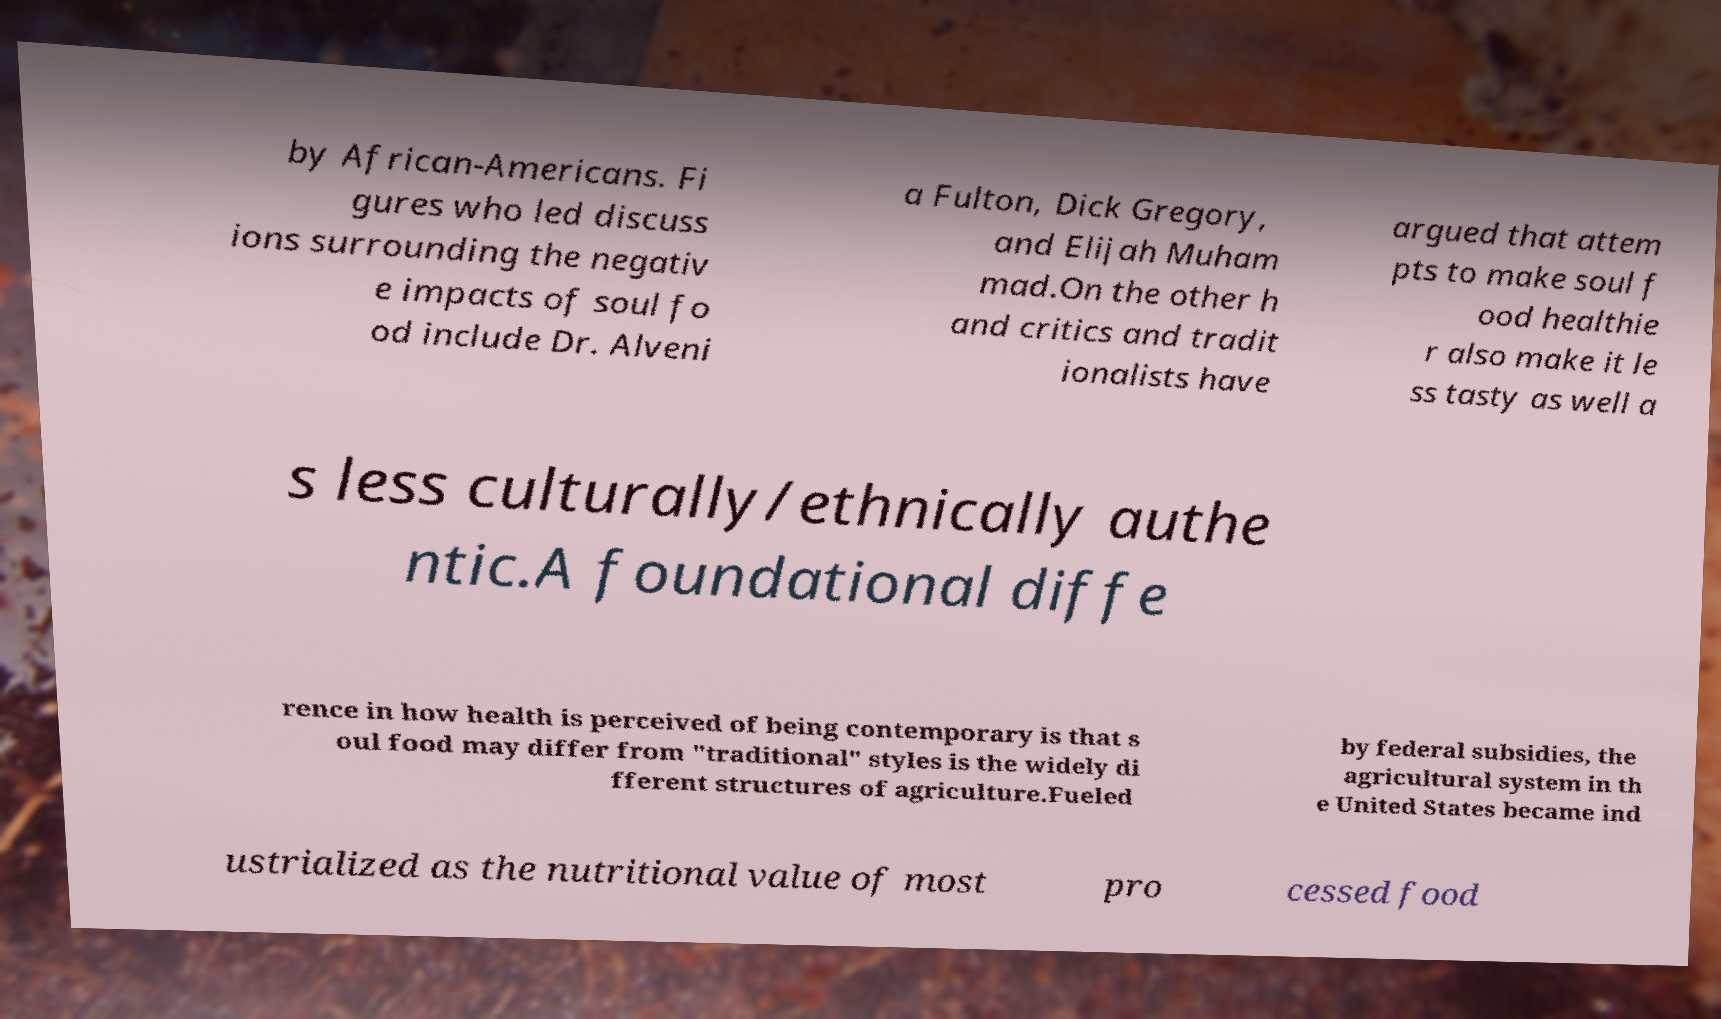Could you extract and type out the text from this image? by African-Americans. Fi gures who led discuss ions surrounding the negativ e impacts of soul fo od include Dr. Alveni a Fulton, Dick Gregory, and Elijah Muham mad.On the other h and critics and tradit ionalists have argued that attem pts to make soul f ood healthie r also make it le ss tasty as well a s less culturally/ethnically authe ntic.A foundational diffe rence in how health is perceived of being contemporary is that s oul food may differ from "traditional" styles is the widely di fferent structures of agriculture.Fueled by federal subsidies, the agricultural system in th e United States became ind ustrialized as the nutritional value of most pro cessed food 